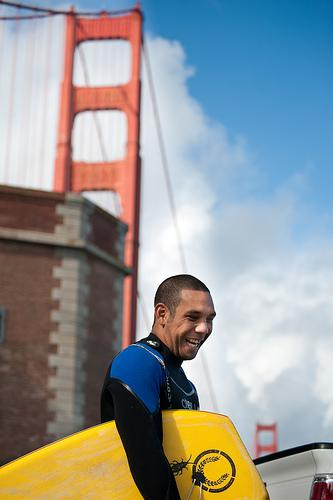Question: when was the picture taken?
Choices:
A. Daytime.
B. At night.
C. At dawn.
D. At dusk.
Answer with the letter. Answer: A Question: who is holding the surfboard?
Choices:
A. The woman.
B. The man.
C. The boy.
D. The girl.
Answer with the letter. Answer: B Question: why is he holding a surfboard?
Choices:
A. He just went surfing.
B. He just bought a surfboard.
C. He is selling a surfboard.
D. He is going surfing.
Answer with the letter. Answer: D 